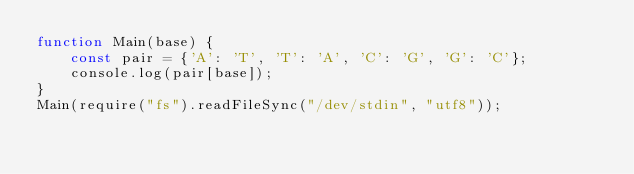<code> <loc_0><loc_0><loc_500><loc_500><_JavaScript_>function Main(base) {
    const pair = {'A': 'T', 'T': 'A', 'C': 'G', 'G': 'C'};
    console.log(pair[base]);
}
Main(require("fs").readFileSync("/dev/stdin", "utf8"));</code> 